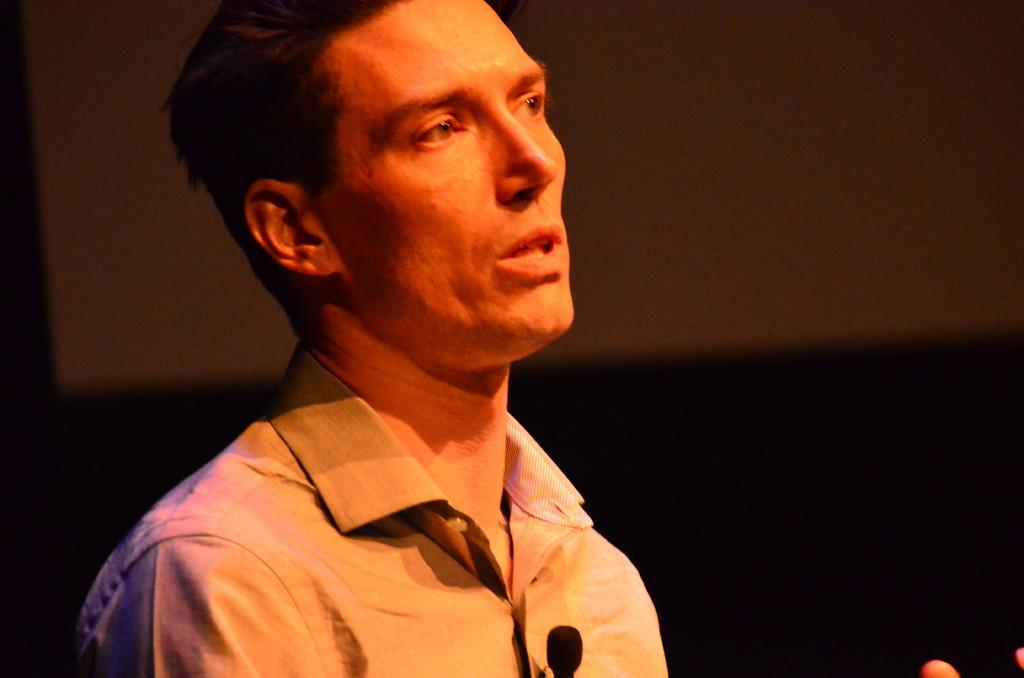Who is the main subject in the image? There is a person in the center of the image. What is the person wearing? The person is wearing a shirt. What is the person's posture in the image? The person appears to be standing. What else can be seen in the image besides the person? There are other objects visible in the background of the image. What type of hook is the person using to hang their shirt in the image? There is no hook present in the image; the person is simply standing and wearing a shirt. What class is the person attending in the image? There is no indication of a class or educational setting in the image. 